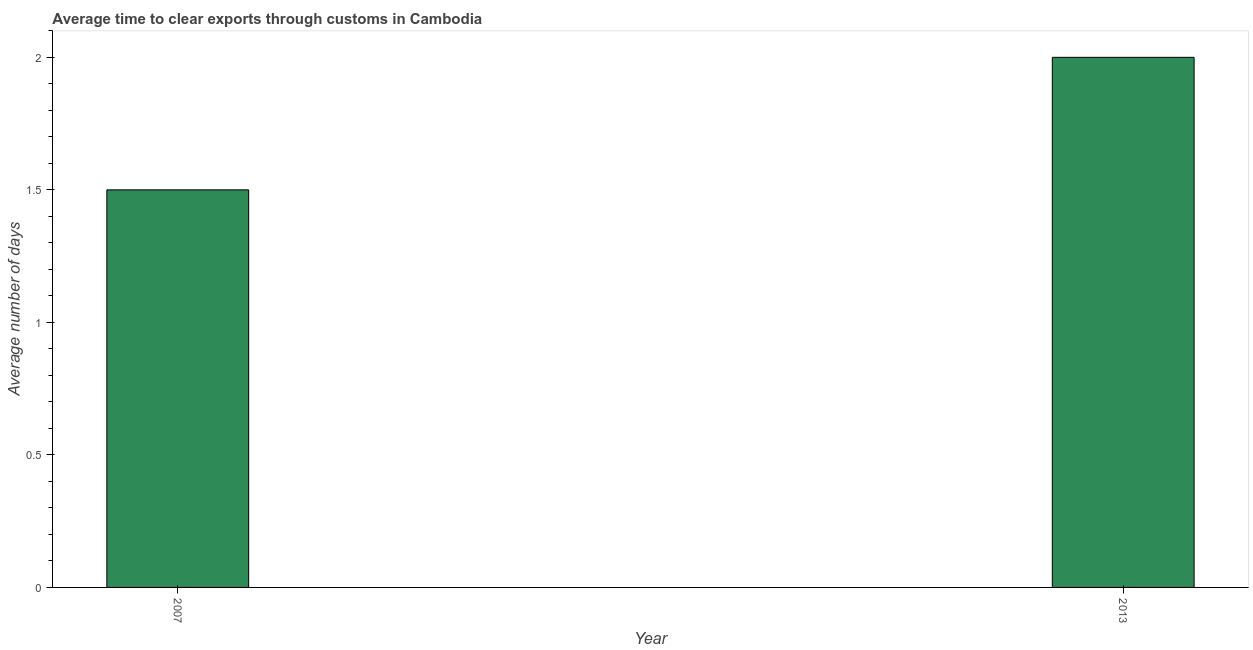Does the graph contain any zero values?
Keep it short and to the point. No. Does the graph contain grids?
Offer a terse response. No. What is the title of the graph?
Your answer should be compact. Average time to clear exports through customs in Cambodia. What is the label or title of the X-axis?
Your response must be concise. Year. What is the label or title of the Y-axis?
Give a very brief answer. Average number of days. What is the time to clear exports through customs in 2013?
Your response must be concise. 2. Across all years, what is the maximum time to clear exports through customs?
Provide a short and direct response. 2. In which year was the time to clear exports through customs minimum?
Keep it short and to the point. 2007. What is the difference between the time to clear exports through customs in 2007 and 2013?
Keep it short and to the point. -0.5. What is the ratio of the time to clear exports through customs in 2007 to that in 2013?
Keep it short and to the point. 0.75. Is the time to clear exports through customs in 2007 less than that in 2013?
Keep it short and to the point. Yes. In how many years, is the time to clear exports through customs greater than the average time to clear exports through customs taken over all years?
Your answer should be very brief. 1. How many bars are there?
Give a very brief answer. 2. Are all the bars in the graph horizontal?
Ensure brevity in your answer.  No. How many years are there in the graph?
Offer a very short reply. 2. What is the difference between two consecutive major ticks on the Y-axis?
Your answer should be very brief. 0.5. What is the ratio of the Average number of days in 2007 to that in 2013?
Ensure brevity in your answer.  0.75. 